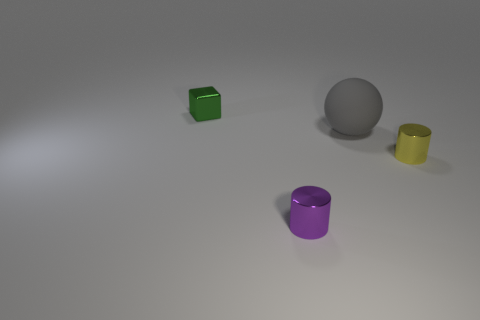Are there fewer purple metal cylinders than tiny gray shiny objects?
Offer a very short reply. No. What number of other objects are the same material as the gray ball?
Provide a succinct answer. 0. The yellow object that is the same shape as the purple thing is what size?
Provide a short and direct response. Small. Does the small cylinder that is right of the big gray matte ball have the same material as the tiny thing that is left of the tiny purple shiny cylinder?
Provide a succinct answer. Yes. Is the number of tiny blocks left of the green cube less than the number of yellow objects?
Ensure brevity in your answer.  Yes. Is there anything else that has the same shape as the small purple metallic thing?
Offer a very short reply. Yes. There is another tiny shiny object that is the same shape as the tiny yellow object; what color is it?
Ensure brevity in your answer.  Purple. There is a cylinder that is to the left of the yellow cylinder; is it the same size as the tiny block?
Offer a very short reply. Yes. There is a metal cylinder right of the tiny shiny cylinder that is on the left side of the tiny yellow cylinder; what is its size?
Give a very brief answer. Small. Is the yellow thing made of the same material as the tiny object that is in front of the tiny yellow metal cylinder?
Offer a terse response. Yes. 